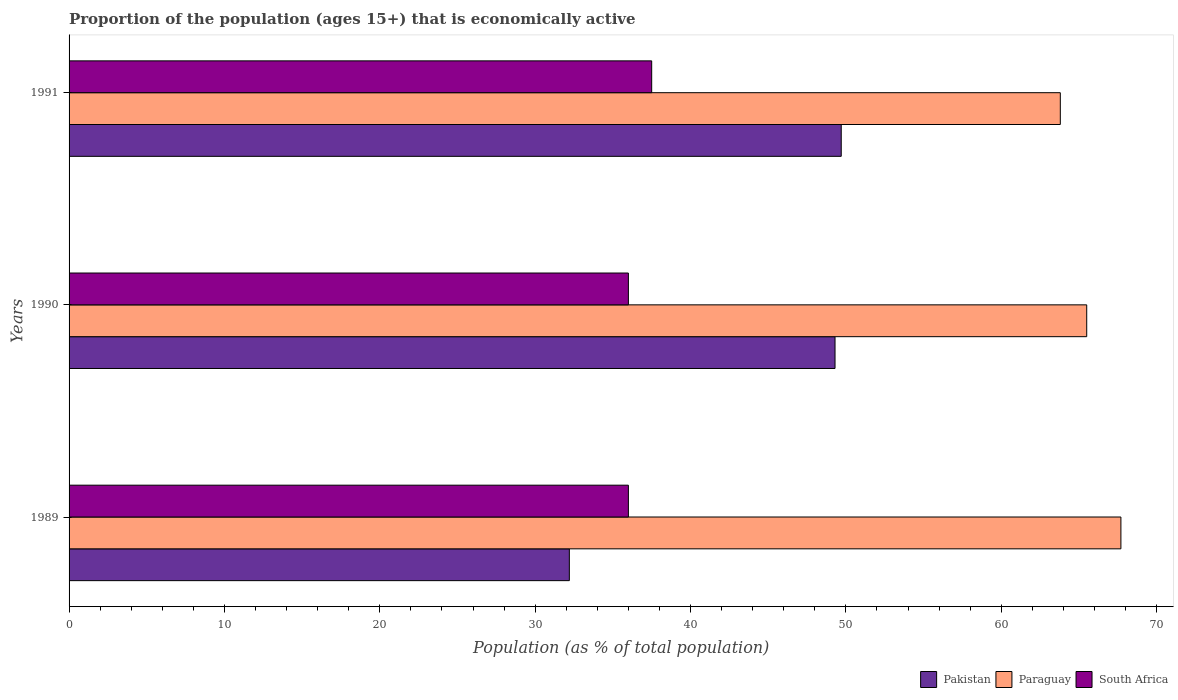Are the number of bars on each tick of the Y-axis equal?
Offer a terse response. Yes. In how many cases, is the number of bars for a given year not equal to the number of legend labels?
Offer a very short reply. 0. What is the proportion of the population that is economically active in Paraguay in 1990?
Give a very brief answer. 65.5. Across all years, what is the maximum proportion of the population that is economically active in South Africa?
Provide a short and direct response. 37.5. Across all years, what is the minimum proportion of the population that is economically active in Paraguay?
Ensure brevity in your answer.  63.8. In which year was the proportion of the population that is economically active in Paraguay maximum?
Your response must be concise. 1989. What is the total proportion of the population that is economically active in South Africa in the graph?
Offer a very short reply. 109.5. What is the difference between the proportion of the population that is economically active in Paraguay in 1989 and that in 1991?
Provide a succinct answer. 3.9. What is the difference between the proportion of the population that is economically active in Pakistan in 1990 and the proportion of the population that is economically active in South Africa in 1991?
Offer a very short reply. 11.8. What is the average proportion of the population that is economically active in Paraguay per year?
Provide a short and direct response. 65.67. In the year 1990, what is the difference between the proportion of the population that is economically active in Pakistan and proportion of the population that is economically active in Paraguay?
Your response must be concise. -16.2. What is the ratio of the proportion of the population that is economically active in South Africa in 1989 to that in 1990?
Give a very brief answer. 1. Is the difference between the proportion of the population that is economically active in Pakistan in 1989 and 1990 greater than the difference between the proportion of the population that is economically active in Paraguay in 1989 and 1990?
Give a very brief answer. No. What is the difference between the highest and the second highest proportion of the population that is economically active in South Africa?
Offer a terse response. 1.5. Is the sum of the proportion of the population that is economically active in Paraguay in 1990 and 1991 greater than the maximum proportion of the population that is economically active in Pakistan across all years?
Your answer should be compact. Yes. What does the 3rd bar from the top in 1989 represents?
Offer a terse response. Pakistan. What does the 3rd bar from the bottom in 1989 represents?
Offer a terse response. South Africa. Is it the case that in every year, the sum of the proportion of the population that is economically active in Paraguay and proportion of the population that is economically active in Pakistan is greater than the proportion of the population that is economically active in South Africa?
Give a very brief answer. Yes. How many bars are there?
Ensure brevity in your answer.  9. Where does the legend appear in the graph?
Offer a very short reply. Bottom right. How are the legend labels stacked?
Your answer should be very brief. Horizontal. What is the title of the graph?
Make the answer very short. Proportion of the population (ages 15+) that is economically active. What is the label or title of the X-axis?
Provide a short and direct response. Population (as % of total population). What is the label or title of the Y-axis?
Offer a very short reply. Years. What is the Population (as % of total population) of Pakistan in 1989?
Make the answer very short. 32.2. What is the Population (as % of total population) of Paraguay in 1989?
Keep it short and to the point. 67.7. What is the Population (as % of total population) in South Africa in 1989?
Give a very brief answer. 36. What is the Population (as % of total population) in Pakistan in 1990?
Your response must be concise. 49.3. What is the Population (as % of total population) in Paraguay in 1990?
Offer a terse response. 65.5. What is the Population (as % of total population) of South Africa in 1990?
Your response must be concise. 36. What is the Population (as % of total population) in Pakistan in 1991?
Your answer should be compact. 49.7. What is the Population (as % of total population) of Paraguay in 1991?
Your response must be concise. 63.8. What is the Population (as % of total population) of South Africa in 1991?
Your answer should be compact. 37.5. Across all years, what is the maximum Population (as % of total population) in Pakistan?
Give a very brief answer. 49.7. Across all years, what is the maximum Population (as % of total population) of Paraguay?
Provide a short and direct response. 67.7. Across all years, what is the maximum Population (as % of total population) in South Africa?
Ensure brevity in your answer.  37.5. Across all years, what is the minimum Population (as % of total population) in Pakistan?
Give a very brief answer. 32.2. Across all years, what is the minimum Population (as % of total population) in Paraguay?
Keep it short and to the point. 63.8. What is the total Population (as % of total population) in Pakistan in the graph?
Your response must be concise. 131.2. What is the total Population (as % of total population) of Paraguay in the graph?
Offer a very short reply. 197. What is the total Population (as % of total population) in South Africa in the graph?
Your answer should be very brief. 109.5. What is the difference between the Population (as % of total population) of Pakistan in 1989 and that in 1990?
Give a very brief answer. -17.1. What is the difference between the Population (as % of total population) in South Africa in 1989 and that in 1990?
Ensure brevity in your answer.  0. What is the difference between the Population (as % of total population) in Pakistan in 1989 and that in 1991?
Provide a short and direct response. -17.5. What is the difference between the Population (as % of total population) in Paraguay in 1989 and that in 1991?
Your answer should be compact. 3.9. What is the difference between the Population (as % of total population) in Pakistan in 1989 and the Population (as % of total population) in Paraguay in 1990?
Offer a terse response. -33.3. What is the difference between the Population (as % of total population) in Pakistan in 1989 and the Population (as % of total population) in South Africa in 1990?
Give a very brief answer. -3.8. What is the difference between the Population (as % of total population) in Paraguay in 1989 and the Population (as % of total population) in South Africa in 1990?
Your answer should be very brief. 31.7. What is the difference between the Population (as % of total population) in Pakistan in 1989 and the Population (as % of total population) in Paraguay in 1991?
Offer a terse response. -31.6. What is the difference between the Population (as % of total population) of Paraguay in 1989 and the Population (as % of total population) of South Africa in 1991?
Your answer should be compact. 30.2. What is the average Population (as % of total population) in Pakistan per year?
Make the answer very short. 43.73. What is the average Population (as % of total population) of Paraguay per year?
Your answer should be compact. 65.67. What is the average Population (as % of total population) in South Africa per year?
Your answer should be very brief. 36.5. In the year 1989, what is the difference between the Population (as % of total population) of Pakistan and Population (as % of total population) of Paraguay?
Your response must be concise. -35.5. In the year 1989, what is the difference between the Population (as % of total population) in Paraguay and Population (as % of total population) in South Africa?
Your answer should be compact. 31.7. In the year 1990, what is the difference between the Population (as % of total population) in Pakistan and Population (as % of total population) in Paraguay?
Offer a very short reply. -16.2. In the year 1990, what is the difference between the Population (as % of total population) of Pakistan and Population (as % of total population) of South Africa?
Offer a very short reply. 13.3. In the year 1990, what is the difference between the Population (as % of total population) in Paraguay and Population (as % of total population) in South Africa?
Offer a very short reply. 29.5. In the year 1991, what is the difference between the Population (as % of total population) in Pakistan and Population (as % of total population) in Paraguay?
Your response must be concise. -14.1. In the year 1991, what is the difference between the Population (as % of total population) in Pakistan and Population (as % of total population) in South Africa?
Offer a very short reply. 12.2. In the year 1991, what is the difference between the Population (as % of total population) of Paraguay and Population (as % of total population) of South Africa?
Offer a very short reply. 26.3. What is the ratio of the Population (as % of total population) of Pakistan in 1989 to that in 1990?
Your answer should be very brief. 0.65. What is the ratio of the Population (as % of total population) in Paraguay in 1989 to that in 1990?
Offer a terse response. 1.03. What is the ratio of the Population (as % of total population) of South Africa in 1989 to that in 1990?
Make the answer very short. 1. What is the ratio of the Population (as % of total population) in Pakistan in 1989 to that in 1991?
Offer a very short reply. 0.65. What is the ratio of the Population (as % of total population) in Paraguay in 1989 to that in 1991?
Provide a short and direct response. 1.06. What is the ratio of the Population (as % of total population) in Paraguay in 1990 to that in 1991?
Provide a succinct answer. 1.03. What is the ratio of the Population (as % of total population) in South Africa in 1990 to that in 1991?
Offer a very short reply. 0.96. What is the difference between the highest and the second highest Population (as % of total population) in Pakistan?
Ensure brevity in your answer.  0.4. What is the difference between the highest and the second highest Population (as % of total population) in South Africa?
Make the answer very short. 1.5. What is the difference between the highest and the lowest Population (as % of total population) of Pakistan?
Provide a short and direct response. 17.5. What is the difference between the highest and the lowest Population (as % of total population) of South Africa?
Your answer should be very brief. 1.5. 